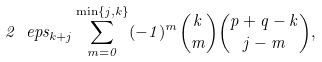<formula> <loc_0><loc_0><loc_500><loc_500>2 \ e p s _ { k + j } \sum _ { m = 0 } ^ { \min \{ j , k \} } ( - 1 ) ^ { m } { k \choose m } { p + q - k \choose j - m } ,</formula> 